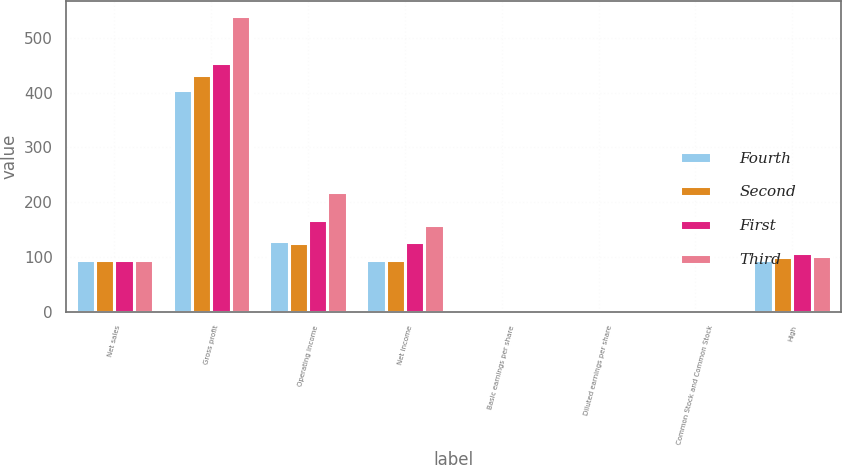<chart> <loc_0><loc_0><loc_500><loc_500><stacked_bar_chart><ecel><fcel>Net sales<fcel>Gross profit<fcel>Operating income<fcel>Net income<fcel>Basic earnings per share<fcel>Diluted earnings per share<fcel>Common Stock and Common Stock<fcel>High<nl><fcel>Fourth<fcel>93.95<fcel>405<fcel>129.1<fcel>93.4<fcel>0.73<fcel>0.73<fcel>0.43<fcel>94.1<nl><fcel>Second<fcel>93.95<fcel>432.8<fcel>125<fcel>93.8<fcel>0.74<fcel>0.73<fcel>0.43<fcel>100.06<nl><fcel>First<fcel>93.95<fcel>453.9<fcel>167.8<fcel>127.7<fcel>1.01<fcel>1<fcel>0.43<fcel>107.05<nl><fcel>Third<fcel>93.95<fcel>540<fcel>219.1<fcel>157.4<fcel>1.25<fcel>1.24<fcel>0.43<fcel>102.01<nl></chart> 